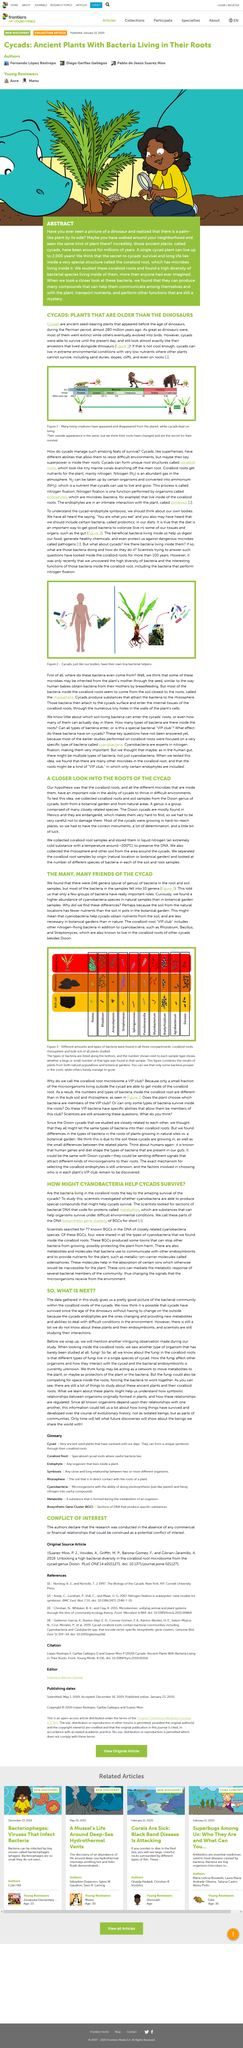Indicate a few pertinent items in this graphic. The caption conveys that the picture features cycads, which have their own microscopic bacterial assistants, similar to how human bodies have microorganisms that aid in their functioning. Cycads are the subject of this article. This article is about cycads, which are plants that belong to a group of ancient plants that have been around for millions of years. Figure 3 displays the different amounts and types of bacteria present in the coralloid roots, rhizosphere, and bulk soil of all plants studied. The root and soil samples contained 246 different genera of bacteria. 